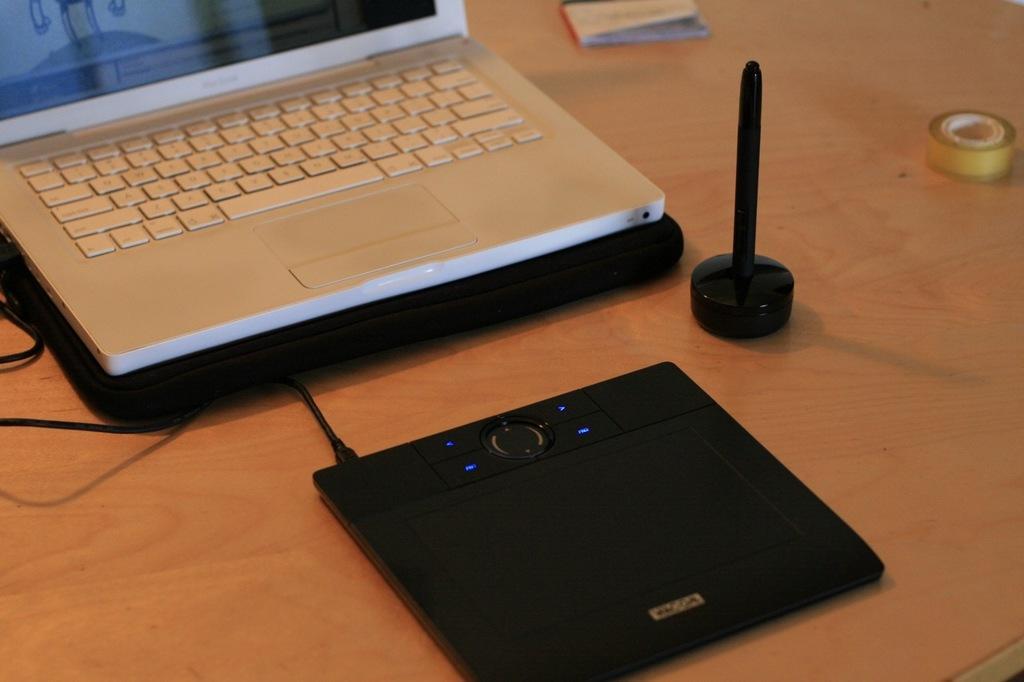Please provide a concise description of this image. On this table there is a laptop, tape, book and device. 